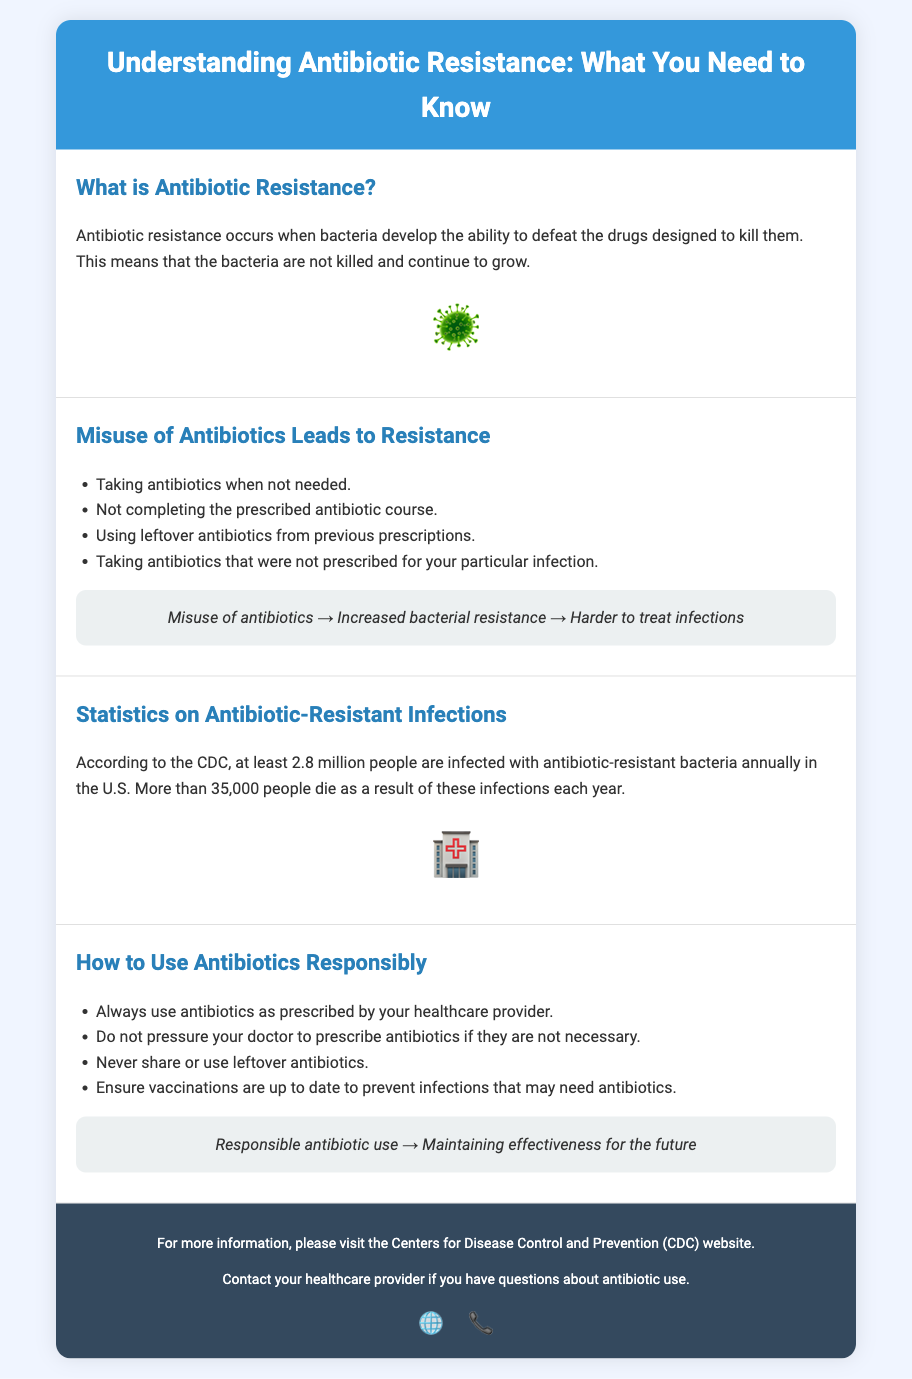What is antibiotic resistance? Antibiotic resistance occurs when bacteria develop the ability to defeat the drugs designed to kill them.
Answer: When bacteria defeat drugs What are two ways misuse of antibiotics can occur? The document lists several ways, including taking antibiotics when not needed and not completing the prescribed course.
Answer: Taking antibiotics when not needed, not completing the prescribed course How many people are infected with antibiotic-resistant bacteria annually in the U.S.? According to the document, at least 2.8 million people are infected each year.
Answer: 2.8 million What is the annual death toll from antibiotic-resistant infections according to the CDC? The document states that more than 35,000 people die each year due to these infections.
Answer: More than 35,000 What should you never do with leftover antibiotics? The document indicates that you should never share or use leftover antibiotics.
Answer: Never share or use leftover antibiotics What must you do to ensure responsible antibiotic use? The document highlights that you should always use antibiotics as prescribed by your healthcare provider.
Answer: Always use antibiotics as prescribed What is the flowchart showing under "Misuse of Antibiotics Leads to Resistance"? The flowchart illustrates the connection between misuse and increased bacterial resistance leading to harder-to-treat infections.
Answer: Misuse of antibiotics → Increased bacterial resistance → Harder to treat infections What organization is recommended for more information about antibiotic use? The document advises visiting the Centers for Disease Control and Prevention (CDC) website for further information.
Answer: Centers for Disease Control and Prevention (CDC) 